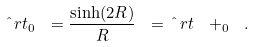<formula> <loc_0><loc_0><loc_500><loc_500>\hat { \ } r t _ { 0 } \ = \frac { \sinh ( 2 R ) } { R } \ = \hat { \ } r t ^ { \ } + _ { 0 } \ .</formula> 